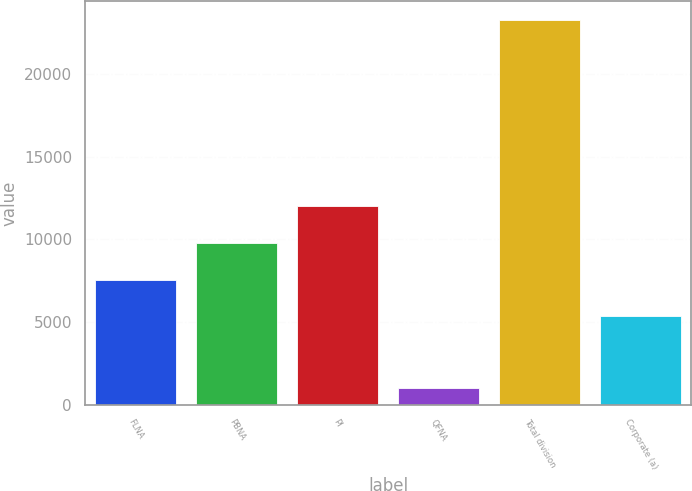Convert chart. <chart><loc_0><loc_0><loc_500><loc_500><bar_chart><fcel>FLNA<fcel>PBNA<fcel>PI<fcel>QFNA<fcel>Total division<fcel>Corporate (a)<nl><fcel>7555.7<fcel>9780.4<fcel>12005.1<fcel>989<fcel>23236<fcel>5331<nl></chart> 